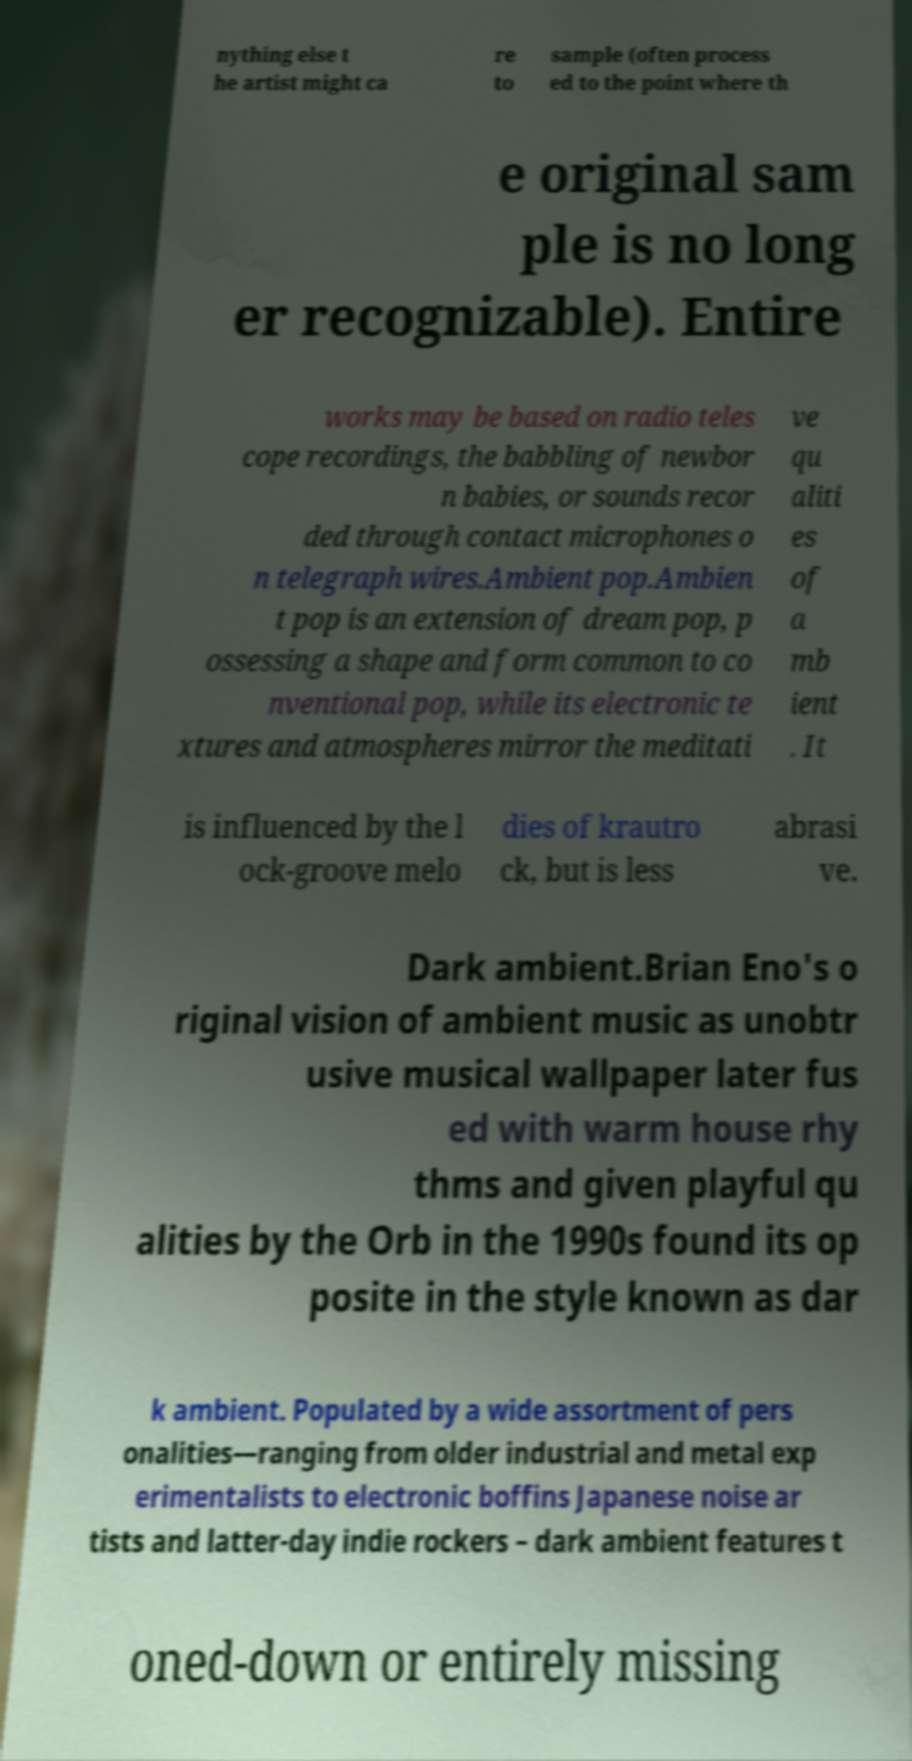Could you assist in decoding the text presented in this image and type it out clearly? nything else t he artist might ca re to sample (often process ed to the point where th e original sam ple is no long er recognizable). Entire works may be based on radio teles cope recordings, the babbling of newbor n babies, or sounds recor ded through contact microphones o n telegraph wires.Ambient pop.Ambien t pop is an extension of dream pop, p ossessing a shape and form common to co nventional pop, while its electronic te xtures and atmospheres mirror the meditati ve qu aliti es of a mb ient . It is influenced by the l ock-groove melo dies of krautro ck, but is less abrasi ve. Dark ambient.Brian Eno's o riginal vision of ambient music as unobtr usive musical wallpaper later fus ed with warm house rhy thms and given playful qu alities by the Orb in the 1990s found its op posite in the style known as dar k ambient. Populated by a wide assortment of pers onalities—ranging from older industrial and metal exp erimentalists to electronic boffins Japanese noise ar tists and latter-day indie rockers – dark ambient features t oned-down or entirely missing 